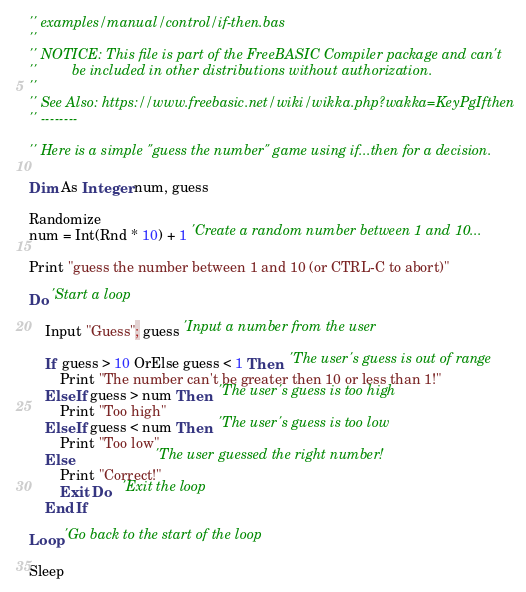Convert code to text. <code><loc_0><loc_0><loc_500><loc_500><_VisualBasic_>'' examples/manual/control/if-then.bas
''
'' NOTICE: This file is part of the FreeBASIC Compiler package and can't
''         be included in other distributions without authorization.
''
'' See Also: https://www.freebasic.net/wiki/wikka.php?wakka=KeyPgIfthen
'' --------

'' Here is a simple "guess the number" game using if...then for a decision.

Dim As Integer num, guess

Randomize
num = Int(Rnd * 10) + 1 'Create a random number between 1 and 10...
				
Print "guess the number between 1 and 10 (or CTRL-C to abort)"

Do 'Start a loop

	Input "Guess"; guess 'Input a number from the user

	If guess > 10 OrElse guess < 1 Then  'The user's guess is out of range
		Print "The number can't be greater then 10 or less than 1!"
	ElseIf guess > num Then  'The user's guess is too high
		Print "Too high"
	ElseIf guess < num Then  'The user's guess is too low
		Print "Too low"
	Else                     'The user guessed the right number!
		Print "Correct!"
		Exit Do   'Exit the loop
	End If

Loop 'Go back to the start of the loop

Sleep
</code> 